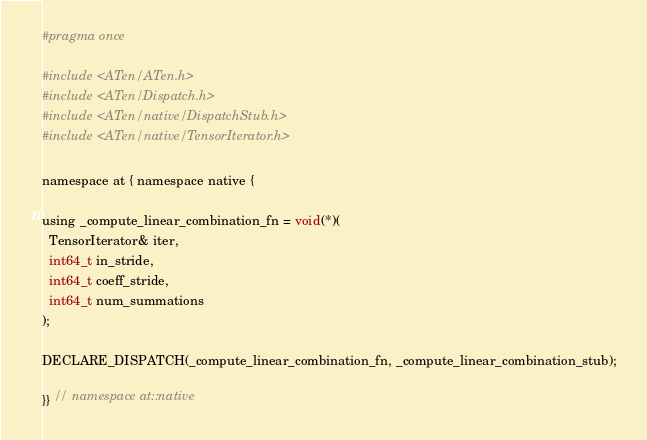Convert code to text. <code><loc_0><loc_0><loc_500><loc_500><_C_>#pragma once

#include <ATen/ATen.h>
#include <ATen/Dispatch.h>
#include <ATen/native/DispatchStub.h>
#include <ATen/native/TensorIterator.h>

namespace at { namespace native {

using _compute_linear_combination_fn = void(*)(
  TensorIterator& iter,
  int64_t in_stride,
  int64_t coeff_stride,
  int64_t num_summations
);

DECLARE_DISPATCH(_compute_linear_combination_fn, _compute_linear_combination_stub);

}} // namespace at::native
</code> 